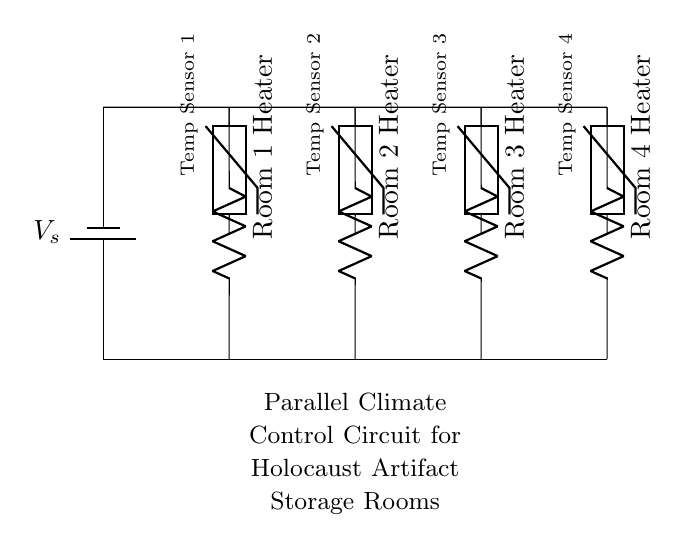What components are used in this circuit? The circuit includes a battery, four resistors (heaters), and four thermistors (temperature sensors). The battery provides the voltage, while the resistors control the heating in the rooms, and the thermistors monitor the temperatures.
Answer: battery, resistors, thermistors How many storage rooms are controlled by this circuit? There are four resistors depicted in the circuit, each representing a heater for a separate storage room, which indicates that the circuit controls four rooms in total.
Answer: four What is the primary function of the thermistors in this circuit? The thermistors are used to sense the temperature in each storage room. They measure the temperature and provide feedback that helps regulate the heating based on the current conditions.
Answer: sensing temperature What happens to the heaters when one of the thermistors indicates a high temperature? The circuit is designed so that if one thermistor indicates a high temperature, the corresponding heater will likely be turned off to avoid overheating in that room. This is a typical feedback mechanism in climate control systems.
Answer: heater turns off What type of circuit is represented here? This circuit is a parallel circuit, where each room's heating system operates independently. In a parallel configuration, each component can be controlled without affecting the others, which is essential for climate control.
Answer: parallel circuit How does the parallel circuit design benefit the climate control system? The parallel design allows individual control of each heater based on the conditions monitored by the thermistors. This means that if one heater needs to be adjusted, it won't impact the other heaters, ensuring optimal conditions for each room.
Answer: individual control 